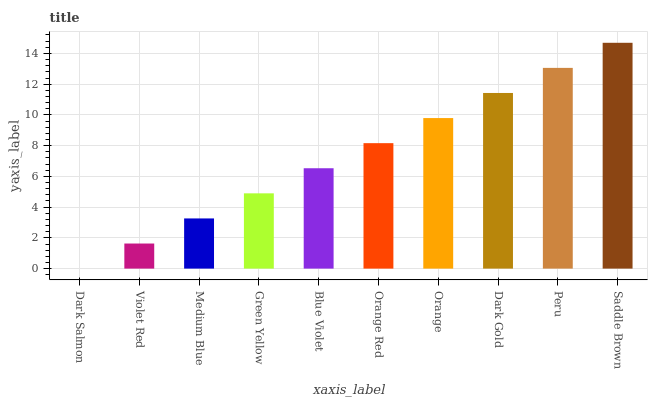Is Violet Red the minimum?
Answer yes or no. No. Is Violet Red the maximum?
Answer yes or no. No. Is Violet Red greater than Dark Salmon?
Answer yes or no. Yes. Is Dark Salmon less than Violet Red?
Answer yes or no. Yes. Is Dark Salmon greater than Violet Red?
Answer yes or no. No. Is Violet Red less than Dark Salmon?
Answer yes or no. No. Is Orange Red the high median?
Answer yes or no. Yes. Is Blue Violet the low median?
Answer yes or no. Yes. Is Blue Violet the high median?
Answer yes or no. No. Is Orange the low median?
Answer yes or no. No. 